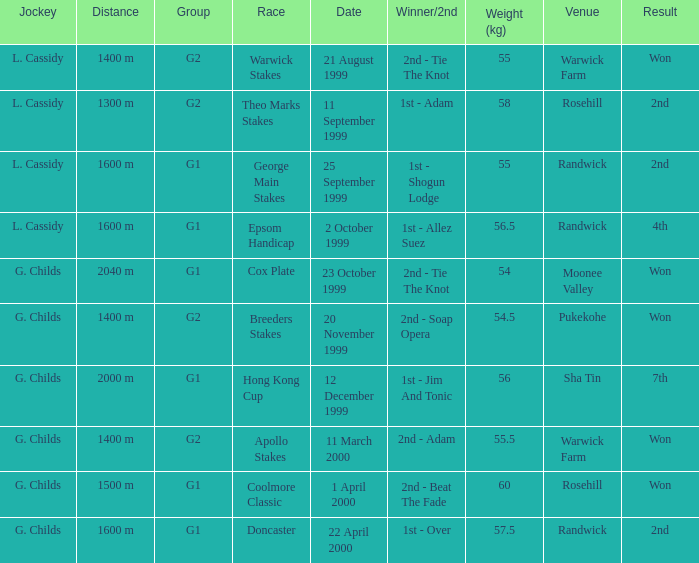How man teams had a total weight of 57.5? 1.0. 